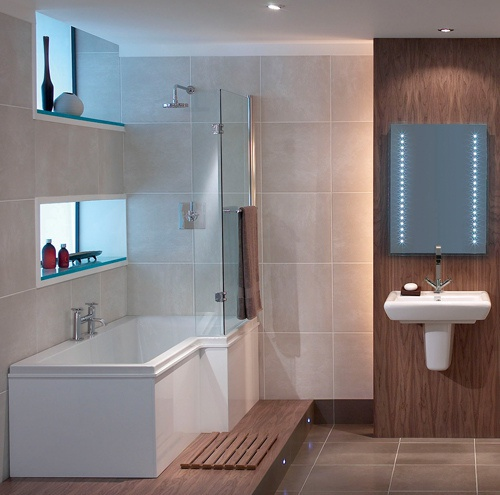Describe the objects in this image and their specific colors. I can see sink in gray and lightgray tones, vase in gray, black, lightblue, and navy tones, vase in gray and blue tones, bottle in gray, maroon, brown, purple, and white tones, and bottle in gray, maroon, black, navy, and blue tones in this image. 